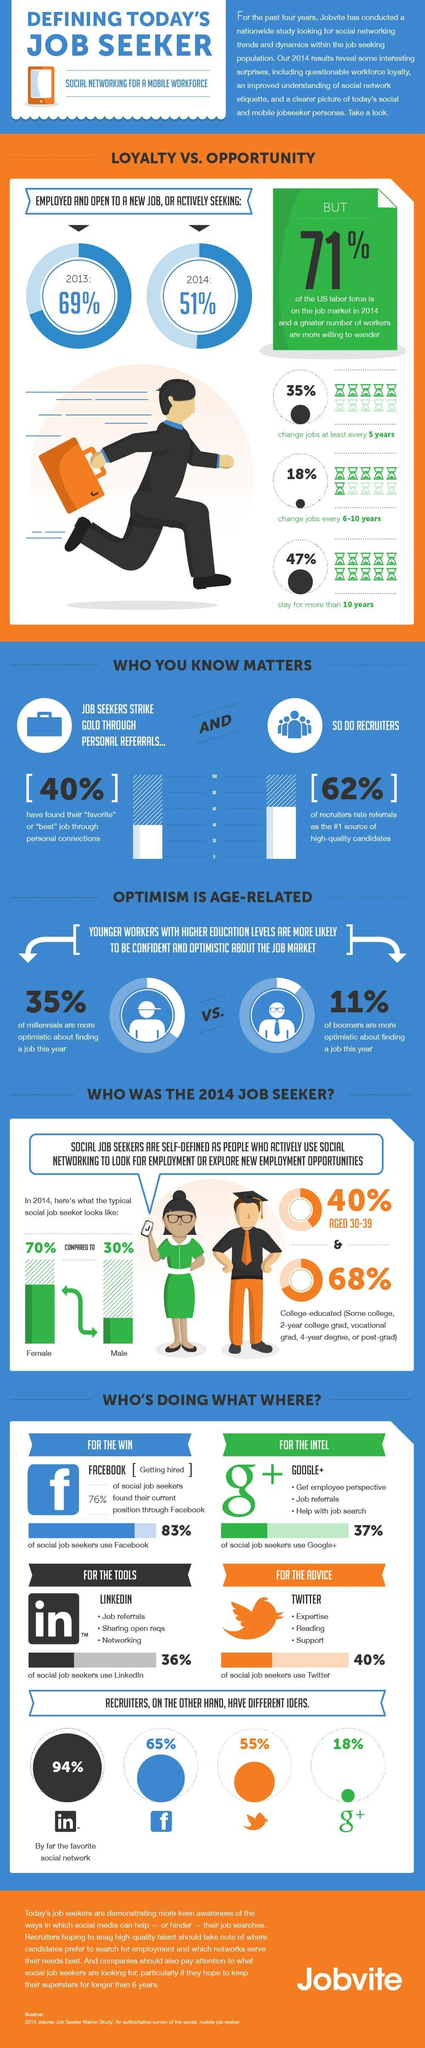What is the colour of the woman's dress- blue, orange or green?
Answer the question with a short phrase. green What percent of recruiters do not think that referrals are #1 source of high quality candidates? 38% What is the colour of the bird Twitter icon- blue, green or orange? orange In which year was more people employed and open to new job? 2013 Who's number is higher in seeking social job? Female 